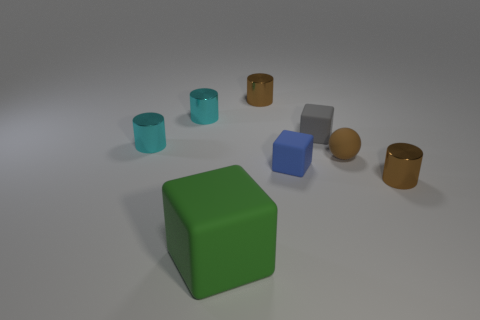What is the texture of the surface that these objects are resting on? The surface looks smooth and has a diffuse, soft appearance. It doesn't seem to reflect light sharply, which indicates that it might have a matte finish. The gentle shadows cast by the objects suggest there's a subtle texture that isn't immediately visible. 